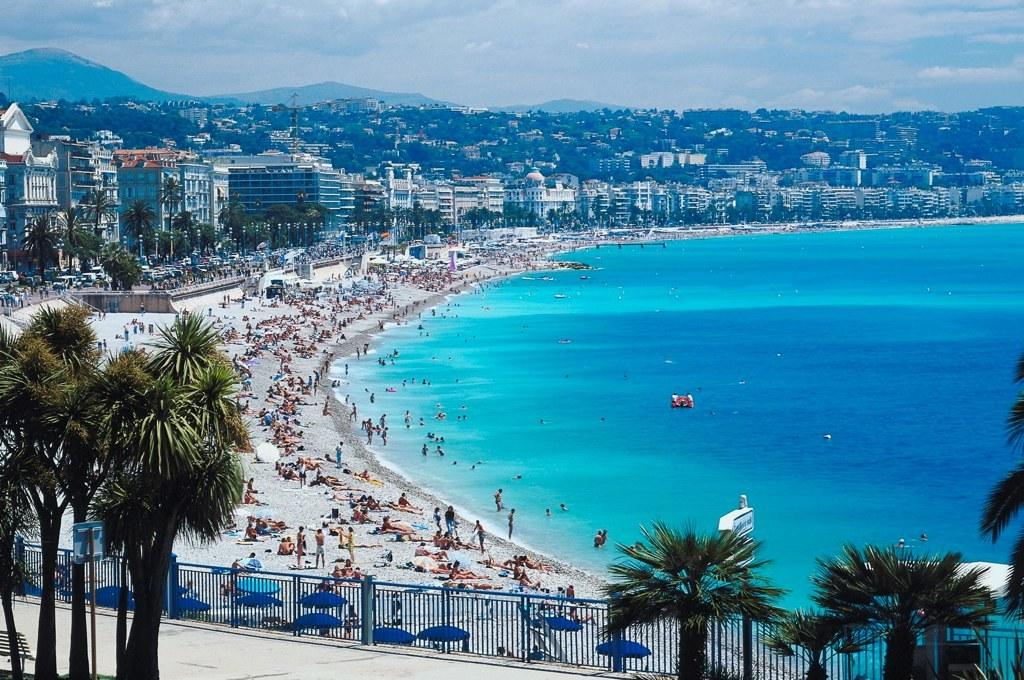What type of structure is at the bottom of the image? There is an iron railing at the bottom of the image. What is happening in the middle of the image? There is a group of people in the middle of the image. What can be seen in the background of the image? There are trees and buildings in the background of the image. What is visible at the top of the image? The sky is visible at the top of the image. What type of pie is being served at the party in the image? There is no party or pie present in the image. Can you see any flames coming from the buildings in the background? There are no flames visible in the image; only trees, buildings, and the sky can be seen. 